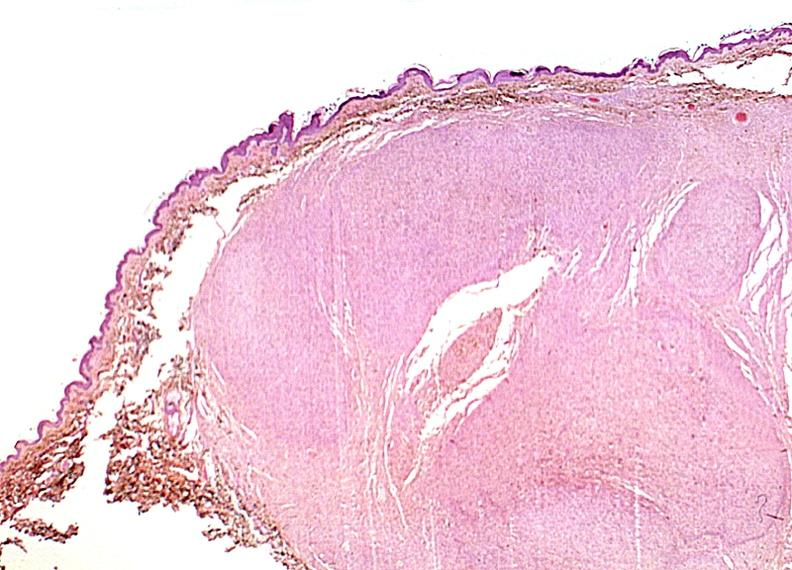what does this image show?
Answer the question using a single word or phrase. Skin 